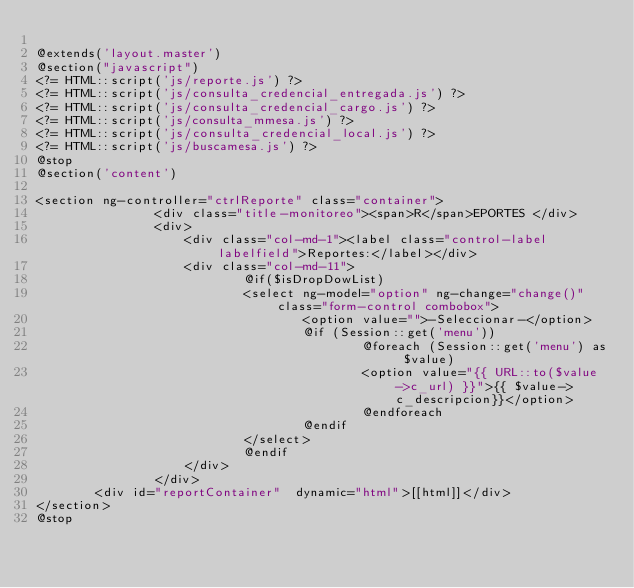Convert code to text. <code><loc_0><loc_0><loc_500><loc_500><_PHP_>
@extends('layout.master')
@section("javascript")        
<?= HTML::script('js/reporte.js') ?> 
<?= HTML::script('js/consulta_credencial_entregada.js') ?>
<?= HTML::script('js/consulta_credencial_cargo.js') ?>
<?= HTML::script('js/consulta_mmesa.js') ?>
<?= HTML::script('js/consulta_credencial_local.js') ?>
<?= HTML::script('js/buscamesa.js') ?> 
@stop
@section('content')

<section ng-controller="ctrlReporte" class="container">
                <div class="title-monitoreo"><span>R</span>EPORTES </div>
                <div>
                    <div class="col-md-1"><label class="control-label labelfield">Reportes:</label></div>
                    <div class="col-md-11">
                            @if($isDropDowList)
                            <select ng-model="option" ng-change="change()" class="form-control combobox">
                                    <option value="">-Seleccionar-</option>
                                    @if (Session::get('menu'))
                                            @foreach (Session::get('menu') as $value)
                                            <option value="{{ URL::to($value->c_url) }}">{{ $value->c_descripcion}}</option>
                                            @endforeach                                
                                    @endif
                            </select>
                            @endif
                    </div>
                </div>
		<div id="reportContainer"  dynamic="html">[[html]]</div>
</section>
@stop

</code> 